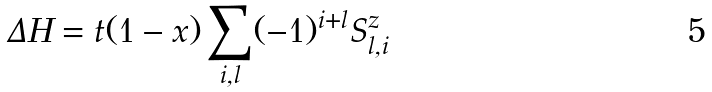Convert formula to latex. <formula><loc_0><loc_0><loc_500><loc_500>\Delta H = t ( 1 - x ) \sum _ { i , l } ( - 1 ) ^ { i + l } S _ { l , i } ^ { z }</formula> 